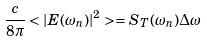<formula> <loc_0><loc_0><loc_500><loc_500>\frac { c } { 8 \pi } < | E ( \omega _ { n } ) | ^ { 2 } > = S _ { T } ( \omega _ { n } ) \Delta \omega</formula> 